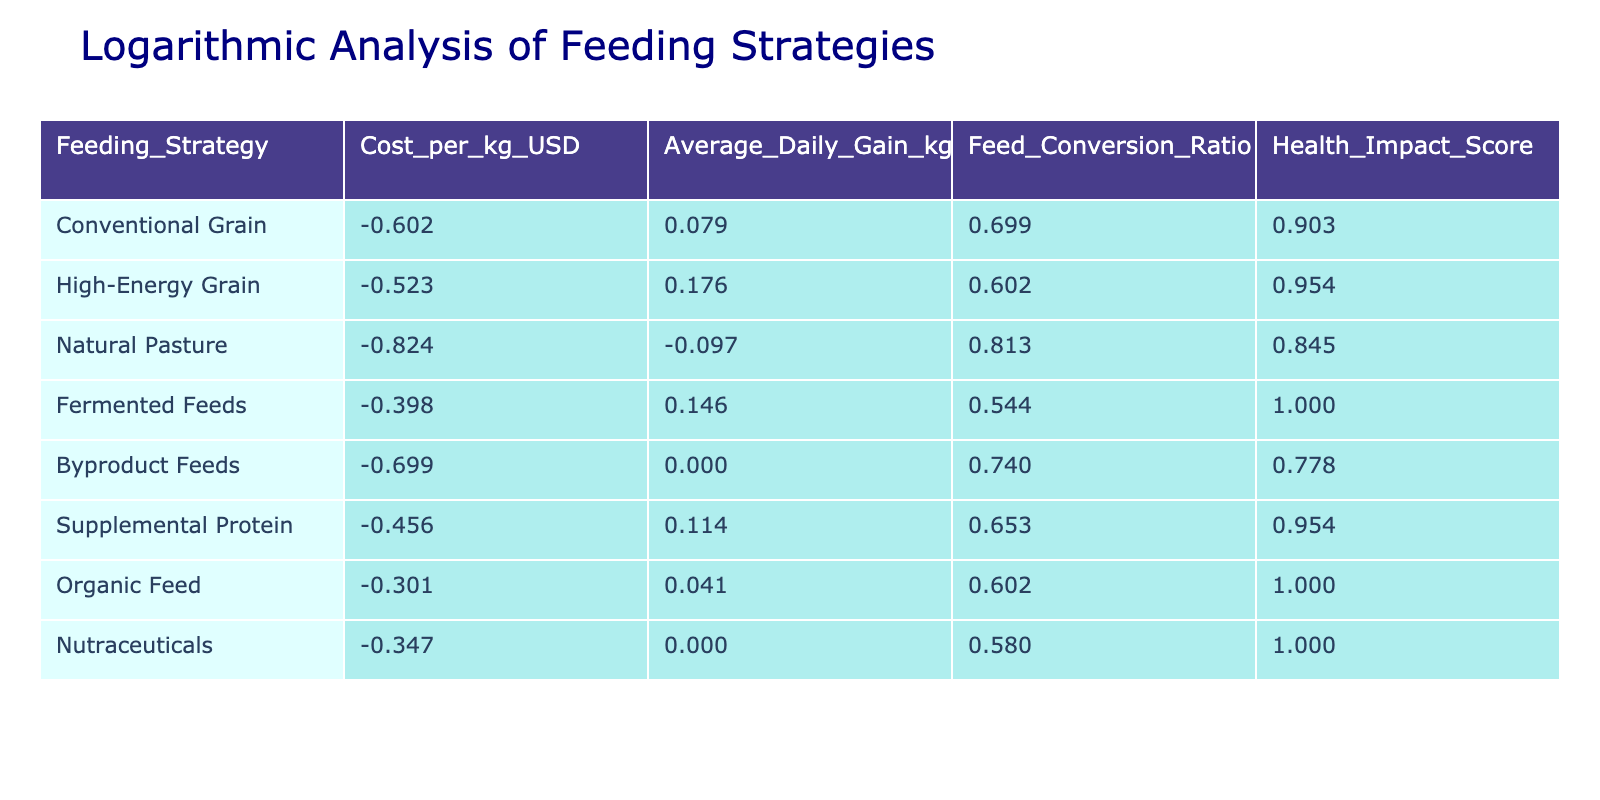What is the cost per kg of Fermented Feeds? The table shows that the cost per kg for Fermented Feeds is listed under the "Cost_per_kg_USD" column. According to the data, this value is 0.40.
Answer: 0.40 Which feeding strategy has the highest Health Impact Score? By scanning the "Health_Impact_Score" column, we can determine that Fermented Feeds and Organic Feed both have the highest score of 10. Thus, these two feeding strategies hold the maximum Health Impact Score.
Answer: Fermented Feeds and Organic Feed What is the Average Daily Gain for Conventional Grain? The "Average_Daily_Gain_kg" column indicates the gain for Conventional Grain as 1.2 kg per day.
Answer: 1.2 Calculate the average cost per kg of the feeding strategies listed. To find the average cost per kg, we sum the values in the "Cost_per_kg_USD" column: (0.25 + 0.30 + 0.15 + 0.40 + 0.20 + 0.35 + 0.50 + 0.45) = 2.40. There are 8 strategies, so the average cost is 2.40 / 8 = 0.30.
Answer: 0.30 Is the Feed Conversion Ratio for Organic Feed lower than that of High-Energy Grain? Looking at the "Feed_Conversion_Ratio" column, Organic Feed has a ratio of 4.0, while High-Energy Grain has a ratio of 4.0 as well. Therefore, they are equal, neither is lower.
Answer: No What is the difference in Average Daily Gain between High-Energy Grain and Natural Pasture? We find the Average Daily Gain for High-Energy Grain as 1.5 kg and for Natural Pasture as 0.8 kg. The difference is calculated as 1.5 - 0.8 = 0.7 kg.
Answer: 0.7 How many feeding strategies have a Feed Conversion Ratio higher than 5.0? By checking the "Feed_Conversion_Ratio" column, we see that Natural Pasture (6.5) and Byproduct Feeds (5.5) are the only strategies that have a ratio higher than 5.0, contributing to a total of 2 strategies.
Answer: 2 Which feeding strategy provides the best Average Daily Gain to cost ratio? We calculate the Average Daily Gain to cost ratio for each strategy by taking Average Daily Gain divided by Cost per kg: For example, for High-Energy Grain, it is 1.5 / 0.30 = 5.0. Conducting this for all strategies, we find that the highest ratio is 5.0 for High-Energy Grain.
Answer: High-Energy Grain Does the cost per kg of Byproduct Feeds exceed that of Natural Pasture? The "Cost_per_kg_USD" for Byproduct Feeds is 0.20, and for Natural Pasture, it is 0.15. Since 0.20 is greater than 0.15, we conclude that the cost of Byproduct Feeds exceeds that of Natural Pasture.
Answer: Yes 